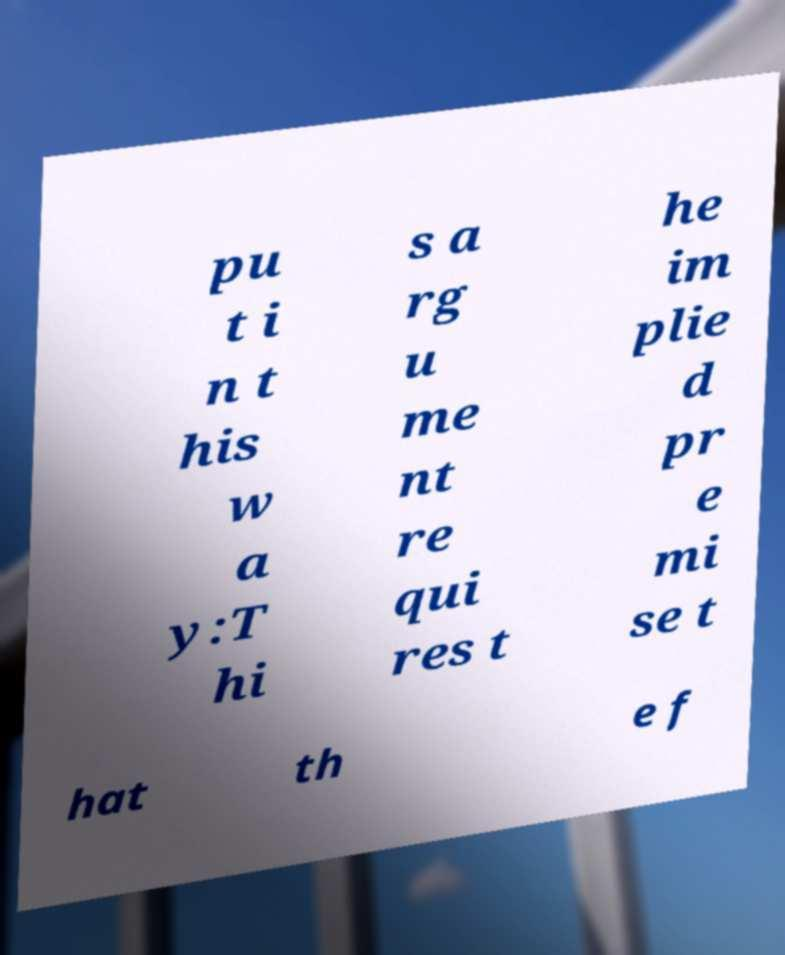Please read and relay the text visible in this image. What does it say? pu t i n t his w a y:T hi s a rg u me nt re qui res t he im plie d pr e mi se t hat th e f 